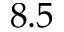<formula> <loc_0><loc_0><loc_500><loc_500>8 . 5</formula> 